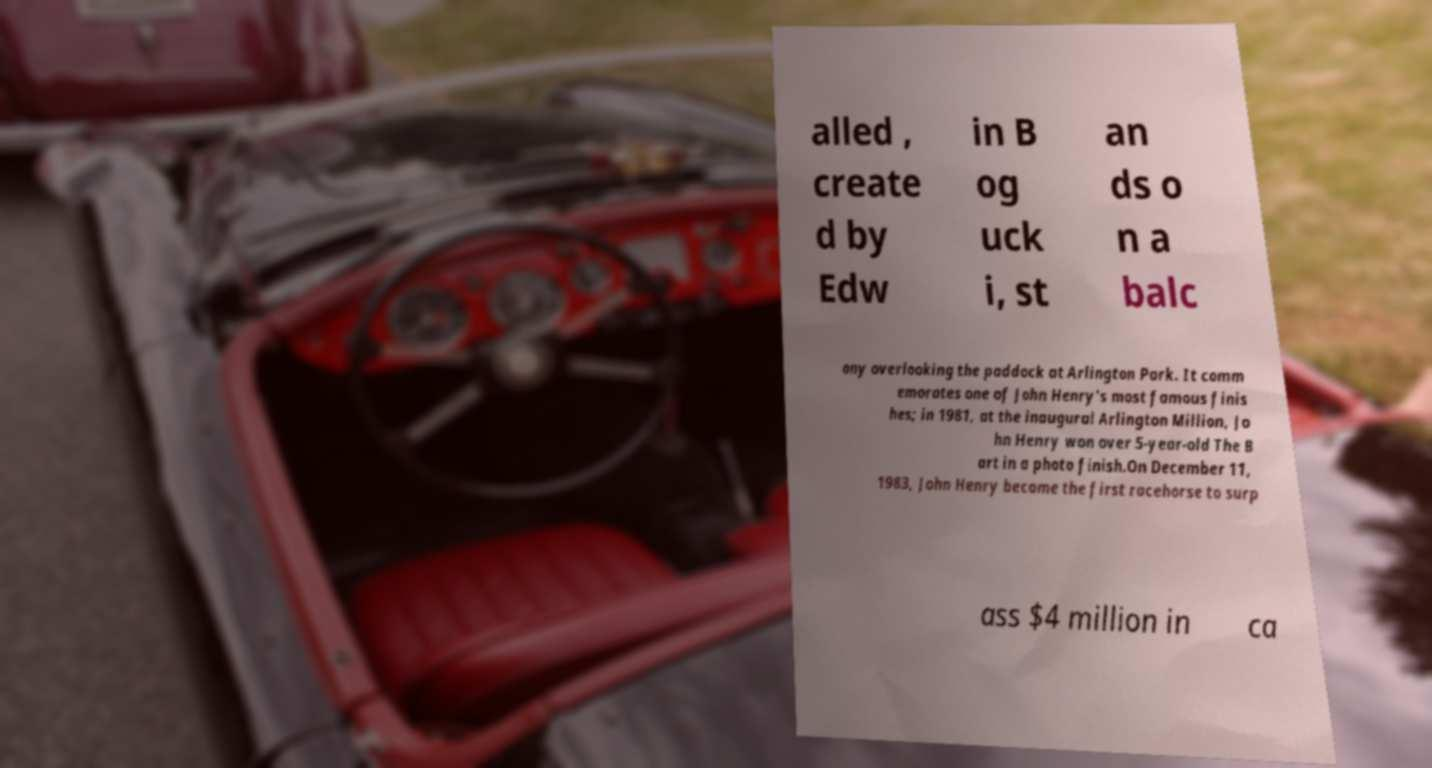Please identify and transcribe the text found in this image. alled , create d by Edw in B og uck i, st an ds o n a balc ony overlooking the paddock at Arlington Park. It comm emorates one of John Henry's most famous finis hes; in 1981, at the inaugural Arlington Million, Jo hn Henry won over 5-year-old The B art in a photo finish.On December 11, 1983, John Henry became the first racehorse to surp ass $4 million in ca 